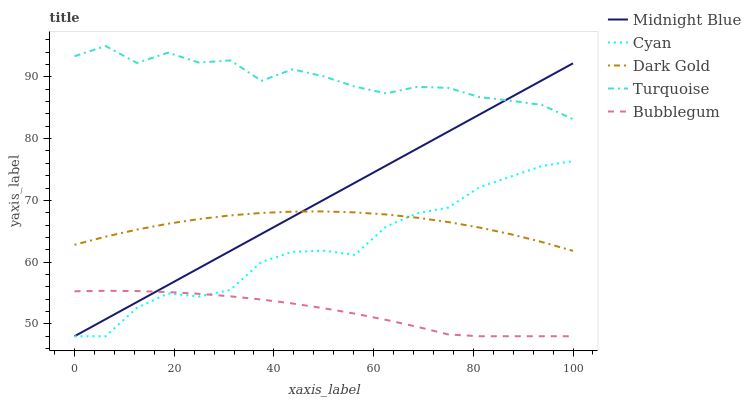Does Bubblegum have the minimum area under the curve?
Answer yes or no. Yes. Does Turquoise have the maximum area under the curve?
Answer yes or no. Yes. Does Midnight Blue have the minimum area under the curve?
Answer yes or no. No. Does Midnight Blue have the maximum area under the curve?
Answer yes or no. No. Is Midnight Blue the smoothest?
Answer yes or no. Yes. Is Turquoise the roughest?
Answer yes or no. Yes. Is Turquoise the smoothest?
Answer yes or no. No. Is Midnight Blue the roughest?
Answer yes or no. No. Does Cyan have the lowest value?
Answer yes or no. Yes. Does Turquoise have the lowest value?
Answer yes or no. No. Does Turquoise have the highest value?
Answer yes or no. Yes. Does Midnight Blue have the highest value?
Answer yes or no. No. Is Cyan less than Turquoise?
Answer yes or no. Yes. Is Turquoise greater than Bubblegum?
Answer yes or no. Yes. Does Turquoise intersect Midnight Blue?
Answer yes or no. Yes. Is Turquoise less than Midnight Blue?
Answer yes or no. No. Is Turquoise greater than Midnight Blue?
Answer yes or no. No. Does Cyan intersect Turquoise?
Answer yes or no. No. 